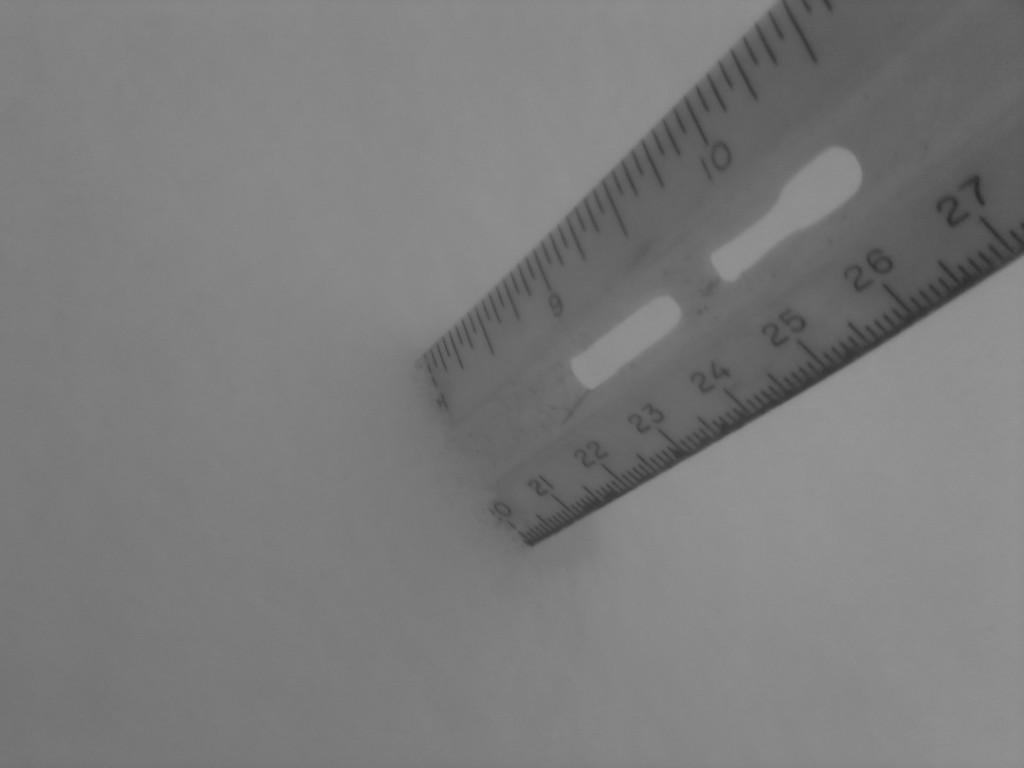What number is on the elft?
Offer a terse response. 20. 